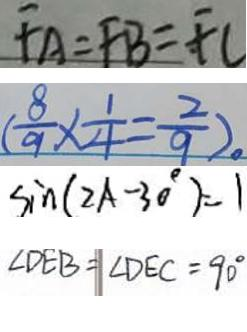Convert formula to latex. <formula><loc_0><loc_0><loc_500><loc_500>F A = F B = F C 
 ( \frac { 8 } { 9 } \times \frac { 1 } { 4 } = \frac { 2 } { 9 } ) 。 
 \sin ( 2 A - 3 0 ^ { \circ } ) = 1 
 \angle D E B = \angle D E C = 9 0 ^ { \circ }</formula> 